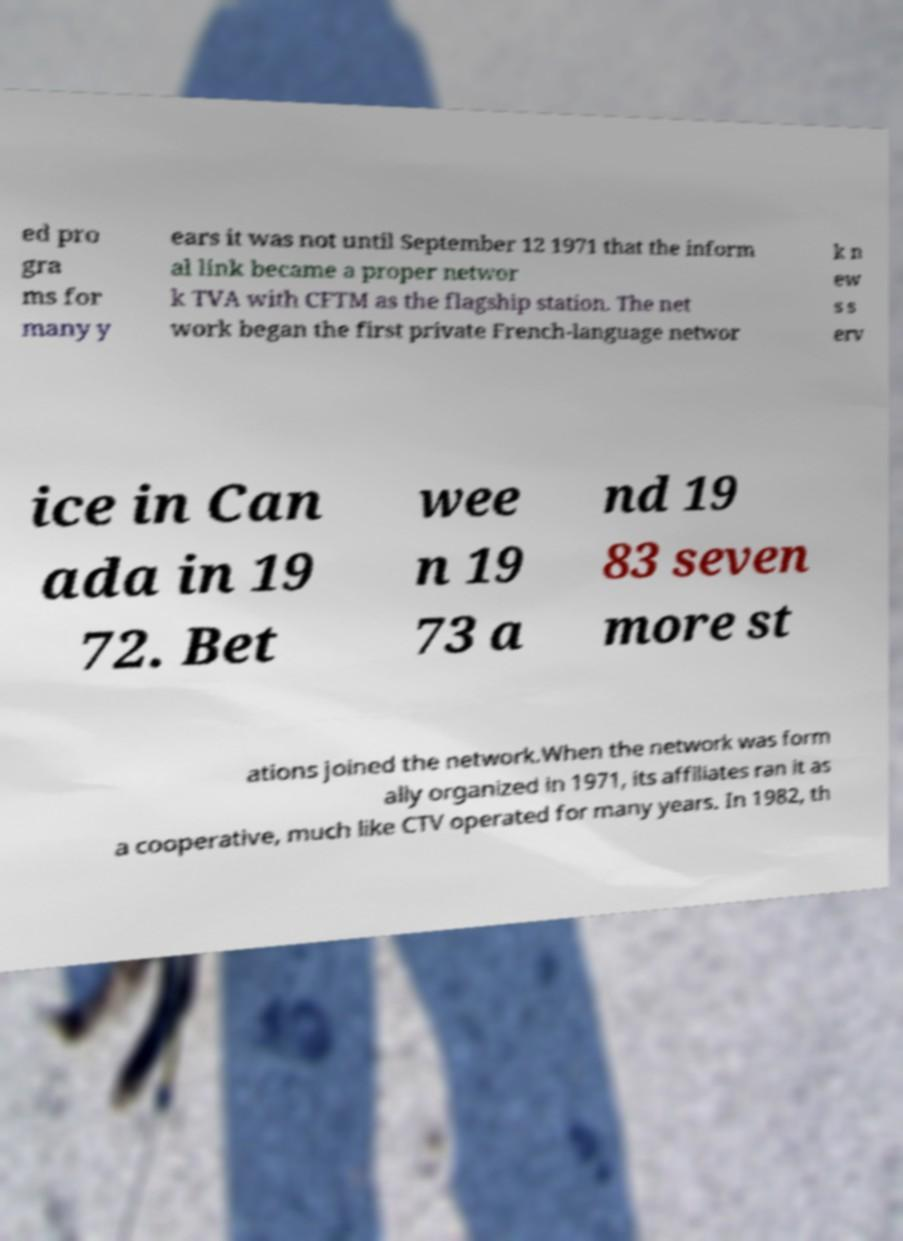Could you assist in decoding the text presented in this image and type it out clearly? ed pro gra ms for many y ears it was not until September 12 1971 that the inform al link became a proper networ k TVA with CFTM as the flagship station. The net work began the first private French-language networ k n ew s s erv ice in Can ada in 19 72. Bet wee n 19 73 a nd 19 83 seven more st ations joined the network.When the network was form ally organized in 1971, its affiliates ran it as a cooperative, much like CTV operated for many years. In 1982, th 